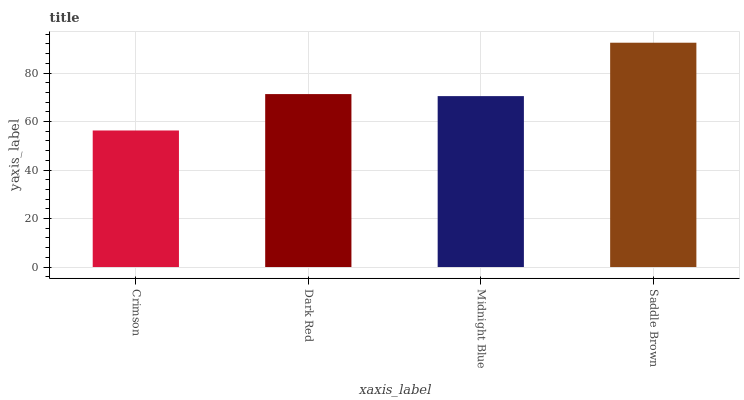Is Crimson the minimum?
Answer yes or no. Yes. Is Saddle Brown the maximum?
Answer yes or no. Yes. Is Dark Red the minimum?
Answer yes or no. No. Is Dark Red the maximum?
Answer yes or no. No. Is Dark Red greater than Crimson?
Answer yes or no. Yes. Is Crimson less than Dark Red?
Answer yes or no. Yes. Is Crimson greater than Dark Red?
Answer yes or no. No. Is Dark Red less than Crimson?
Answer yes or no. No. Is Dark Red the high median?
Answer yes or no. Yes. Is Midnight Blue the low median?
Answer yes or no. Yes. Is Saddle Brown the high median?
Answer yes or no. No. Is Saddle Brown the low median?
Answer yes or no. No. 